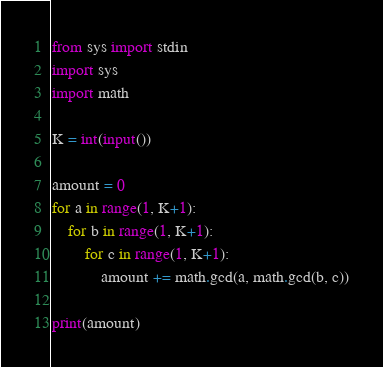<code> <loc_0><loc_0><loc_500><loc_500><_Python_>from sys import stdin
import sys
import math

K = int(input())

amount = 0
for a in range(1, K+1):
    for b in range(1, K+1):
        for c in range(1, K+1):
            amount += math.gcd(a, math.gcd(b, c))

print(amount)
</code> 